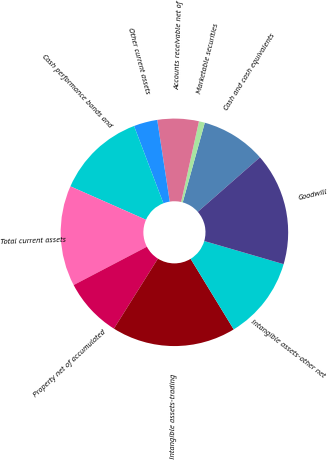<chart> <loc_0><loc_0><loc_500><loc_500><pie_chart><fcel>Cash and cash equivalents<fcel>Marketable securities<fcel>Accounts receivable net of<fcel>Other current assets<fcel>Cash performance bonds and<fcel>Total current assets<fcel>Property net of accumulated<fcel>Intangible assets-trading<fcel>Intangible assets-other net<fcel>Goodwill<nl><fcel>9.24%<fcel>0.84%<fcel>5.88%<fcel>3.36%<fcel>12.6%<fcel>14.29%<fcel>8.4%<fcel>17.65%<fcel>11.76%<fcel>15.97%<nl></chart> 